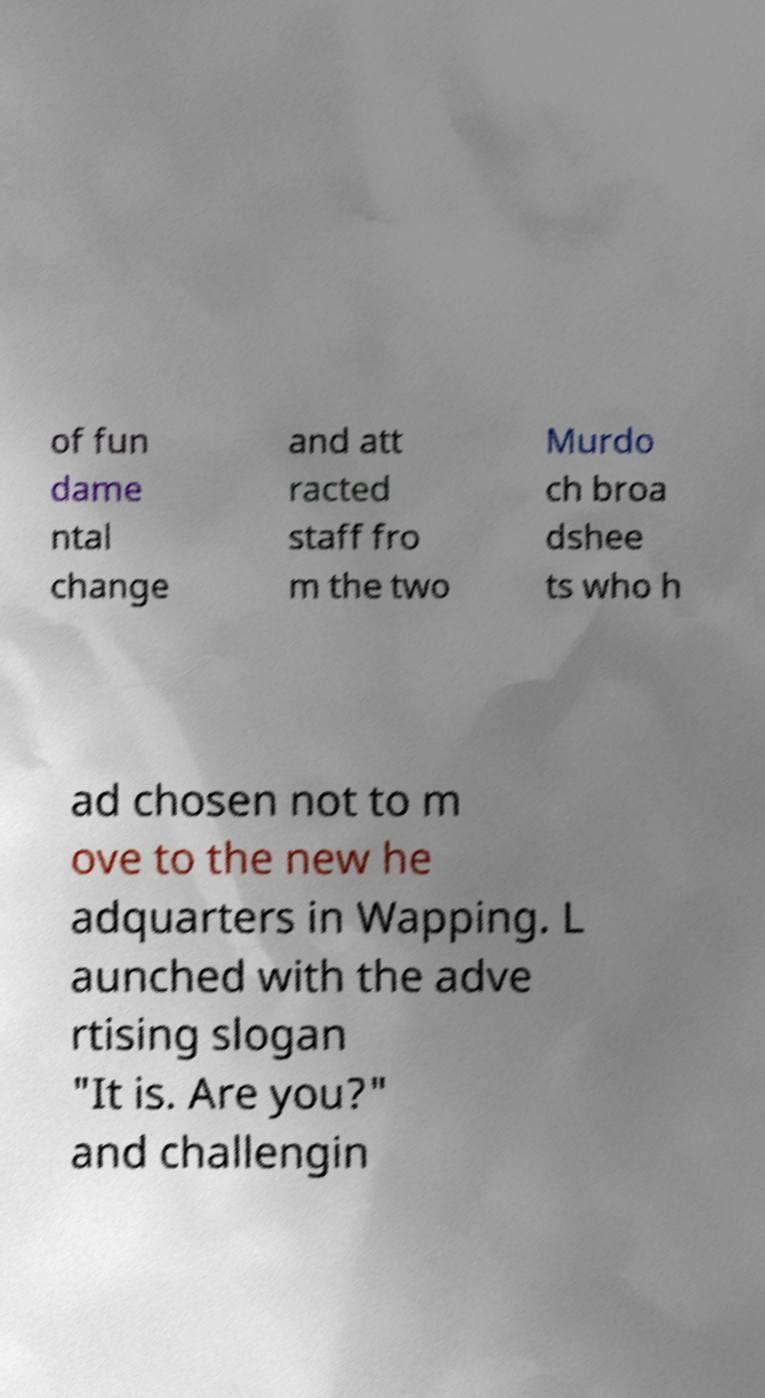Please identify and transcribe the text found in this image. of fun dame ntal change and att racted staff fro m the two Murdo ch broa dshee ts who h ad chosen not to m ove to the new he adquarters in Wapping. L aunched with the adve rtising slogan "It is. Are you?" and challengin 